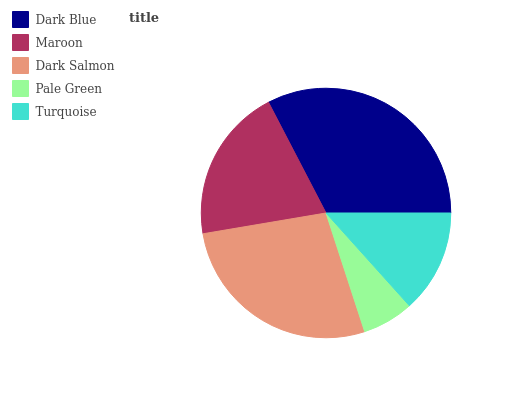Is Pale Green the minimum?
Answer yes or no. Yes. Is Dark Blue the maximum?
Answer yes or no. Yes. Is Maroon the minimum?
Answer yes or no. No. Is Maroon the maximum?
Answer yes or no. No. Is Dark Blue greater than Maroon?
Answer yes or no. Yes. Is Maroon less than Dark Blue?
Answer yes or no. Yes. Is Maroon greater than Dark Blue?
Answer yes or no. No. Is Dark Blue less than Maroon?
Answer yes or no. No. Is Maroon the high median?
Answer yes or no. Yes. Is Maroon the low median?
Answer yes or no. Yes. Is Turquoise the high median?
Answer yes or no. No. Is Dark Salmon the low median?
Answer yes or no. No. 